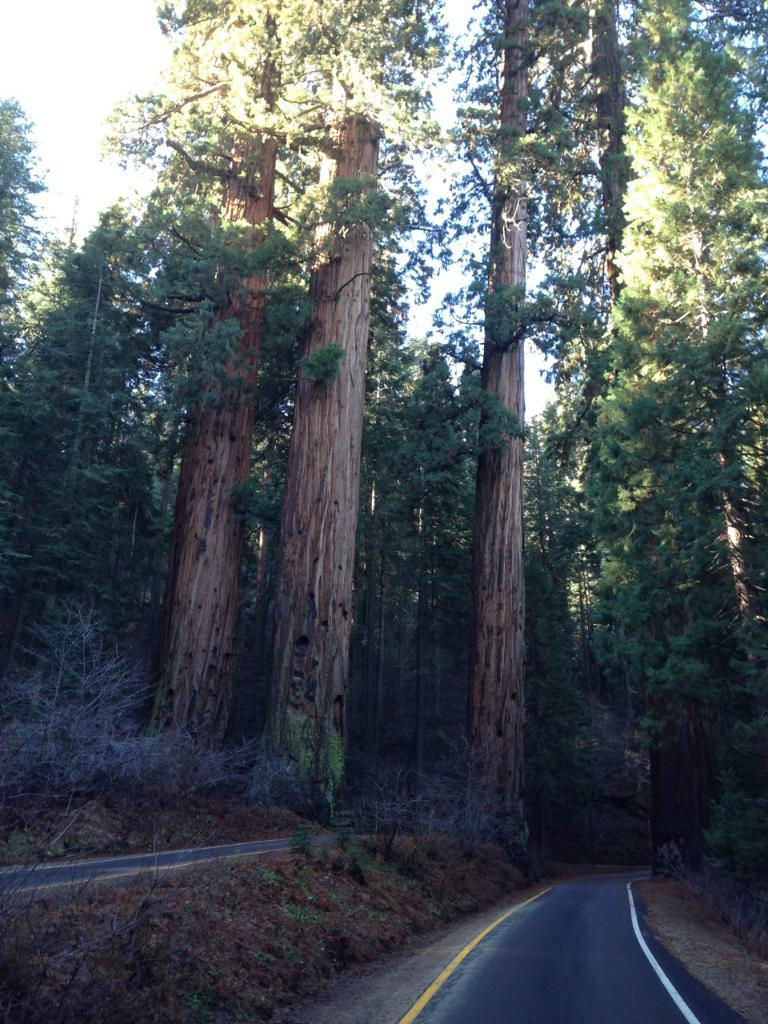What type of vegetation can be seen in the image? There are trees in the image. What type of man-made structures are present in the image? There are roads in the image. What type of natural surface is visible in the image? There is ground with plants in the image. What part of the natural environment is visible in the image? The sky is visible in the image. What type of bells can be heard ringing in the image? There are no bells present in the image, and therefore no sound can be heard. What month is depicted in the image? The image does not depict a specific month; it only shows trees, roads, ground with plants, and the sky. 